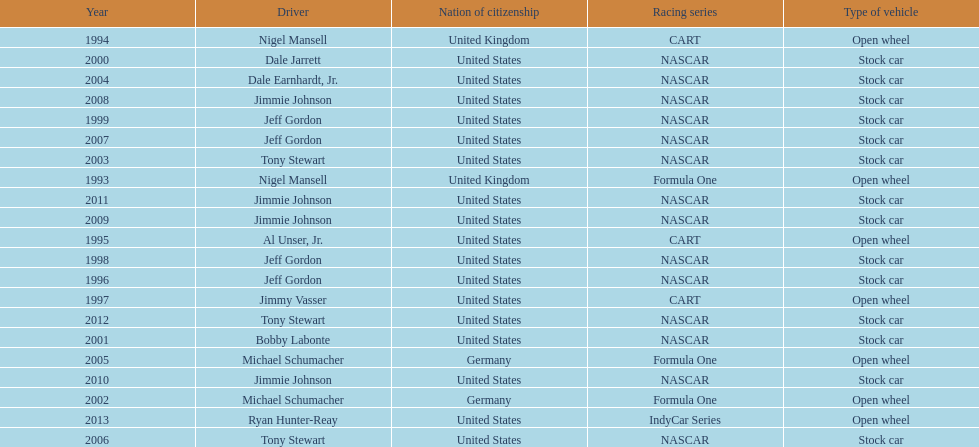Does the united states have more nation of citzenship then united kingdom? Yes. 